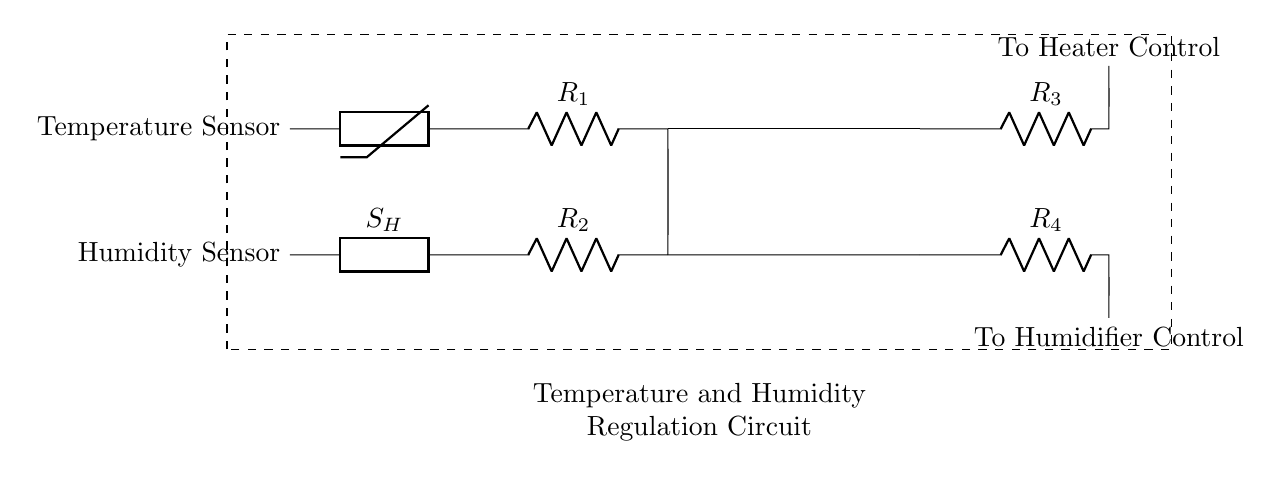What type of sensors are used in this circuit? The circuit includes a temperature sensor and a humidity sensor, which are explicitly labeled in the diagram on the left side.
Answer: temperature sensor and humidity sensor What is the function of the op-amps in this circuit? The op-amps amplify the signals from the temperature and humidity sensors, allowing them to control the heater and humidifier more effectively. The circuit shows two separate op-amps, one for each sensor type.
Answer: signal amplification How many resistors are present in the circuit? There are four resistors present in the circuit, indicated by the labels R1, R2, R3, and R4 connected to various points in the circuit.
Answer: four What do the outputs from the op-amps control? The outputs from the op-amps control the heater and humidifier, which are specified in the diagram as "To Heater Control" and "To Humidifier Control," respectively.
Answer: heater and humidifier How does the temperature sensor connect to the circuit? The temperature sensor connects through a thermistor to resistor R1, and then continues toward the operational amplifier, indicating the flow of the signal processed by the sensor.
Answer: through a thermistor to R1 What will happen if the temperature rises too much in the circuit? If the temperature rises too much, the op-amp responsible for heat control will trigger a response to reduce the temperature, likely by activating a cooling mechanism or controlling the heater to turn off.
Answer: the heater turns off 